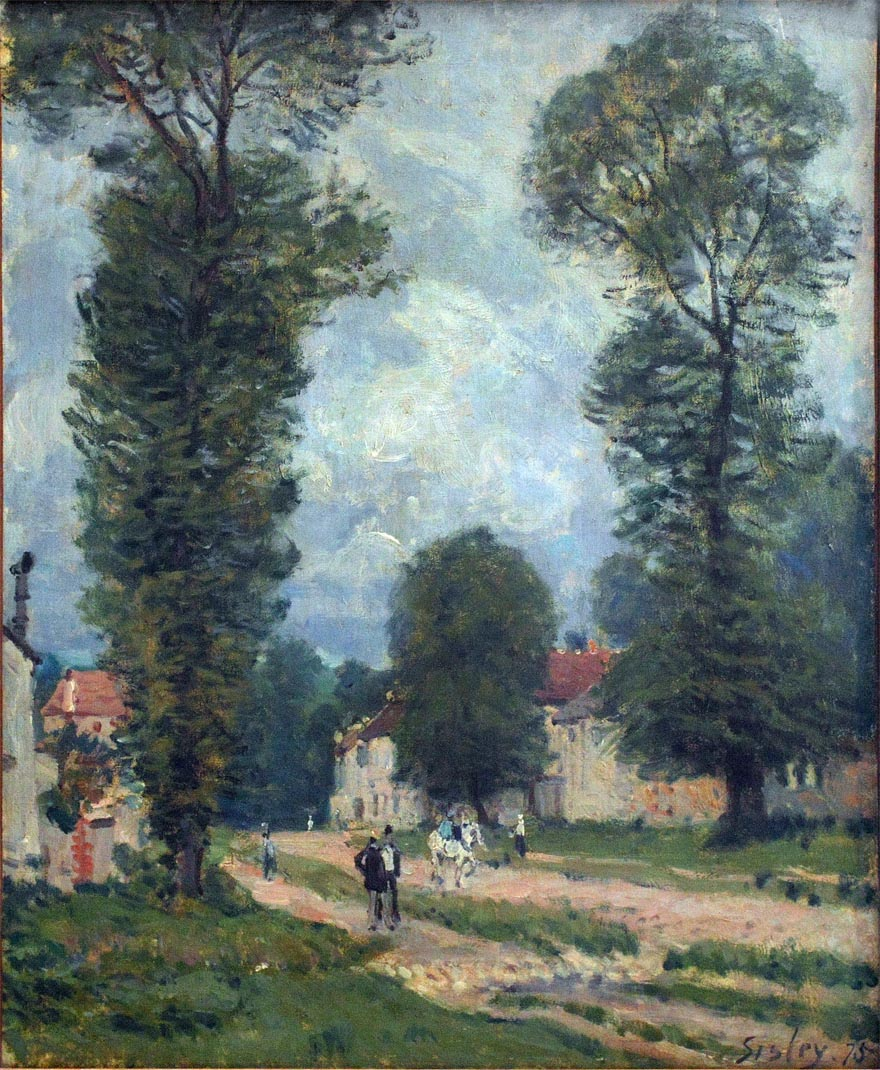What details can you tell me about the architecture in the painting? The architecture in the painting reveals quaint rural houses with reddish-orange roofs that contrast beautifully against the greenery. These buildings appear to be simple yet sturdy, reflecting the rustic charm of the countryside. The walls are painted in a pale tone, likely white or cream, which gives them an inviting and warm appearance. They are nestled comfortably within the lush foliage, suggesting a harmonious blend between man-made structures and nature. Do you think these buildings have any historical significance? While the painting does not provide explicit historical details, buildings like these in rural European landscapes often hold rich cultural and historical significance. They might have been homes to generations of families, possibly serving as farms or local inns. The style suggests they could date back to the 19th century, which aligns with the period Sisley painted in. Their preservation and depiction in art highlight their importance in the social and daily life of the rural community. 